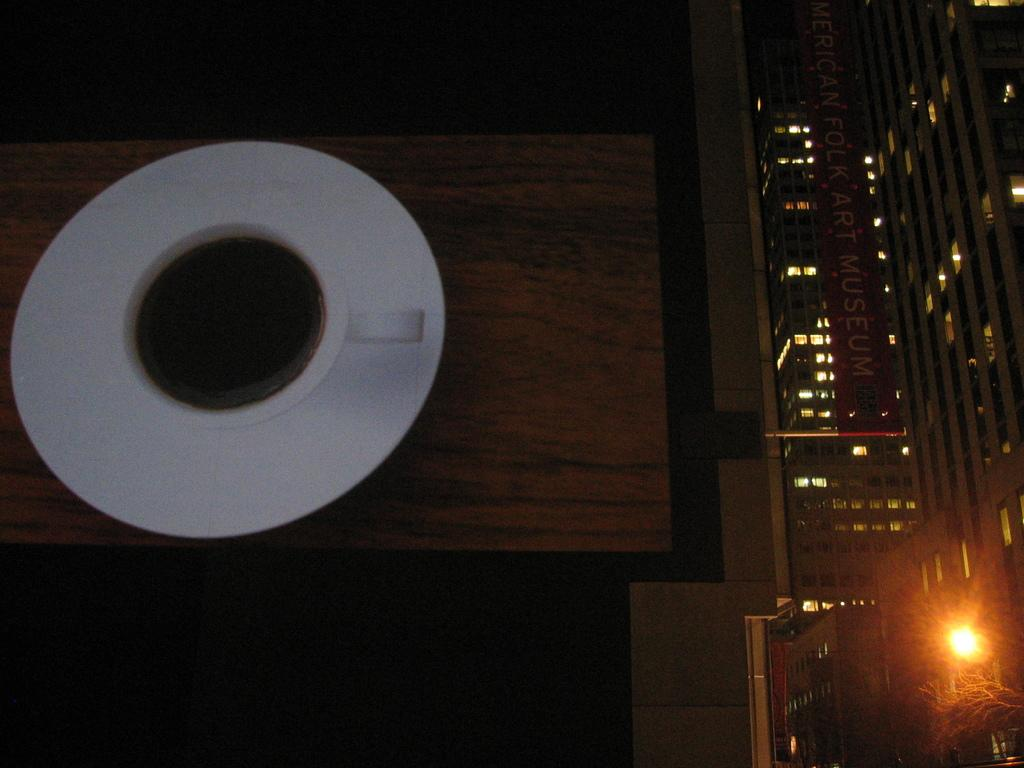What objects are on the left side of the image? There is a cup and saucer on the left side of the image. What can be seen on the right side of the image? There are buildings on the right side of the image. Can you describe the light in the image? There is a yellow color light on the bottom right side of the image. How many visitors can be seen in the image? There is no indication of any visitors in the image. What type of destruction is depicted in the image? There is no destruction depicted in the image; it features a cup and saucer, buildings, and a yellow light. 